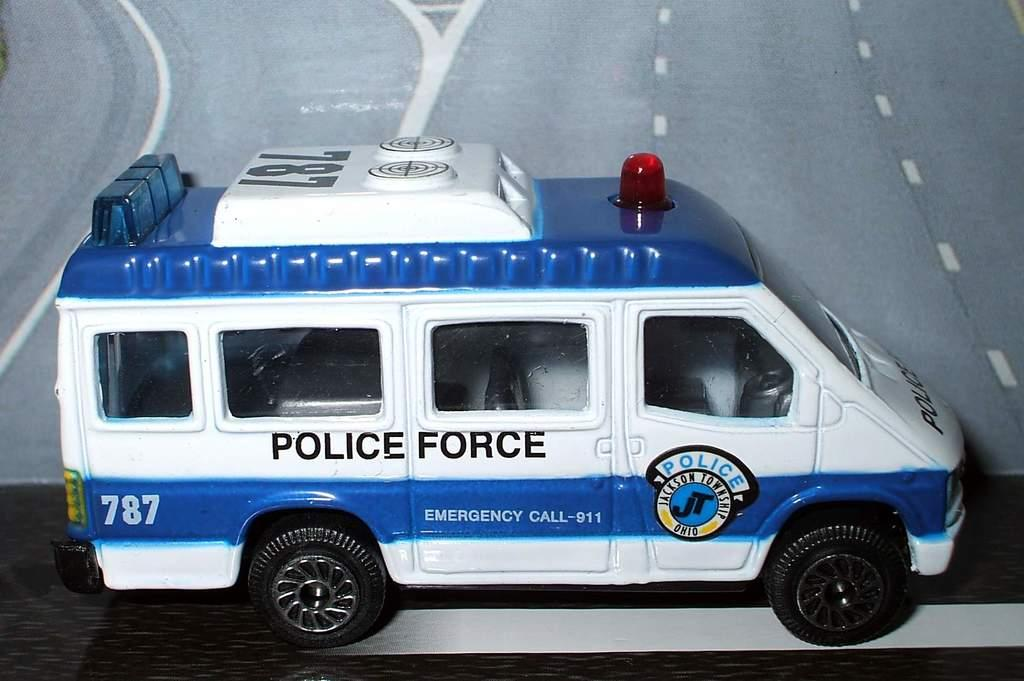What type of toy can be seen in the image? There is a toy in the image that resembles a police van. What is the setting of the image? There is a road depicted in the image. What is the rate at which the cattle are flying in the image? There are no cattle or flying depicted in the image; it features a toy police van and a road. 